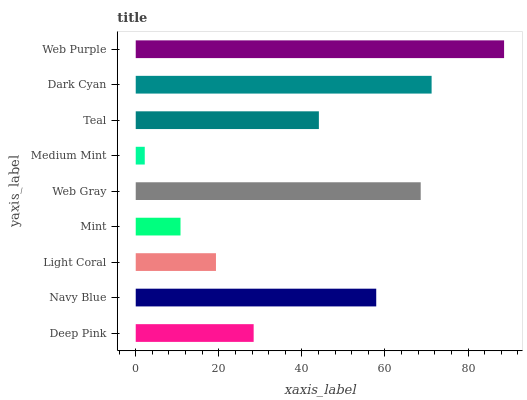Is Medium Mint the minimum?
Answer yes or no. Yes. Is Web Purple the maximum?
Answer yes or no. Yes. Is Navy Blue the minimum?
Answer yes or no. No. Is Navy Blue the maximum?
Answer yes or no. No. Is Navy Blue greater than Deep Pink?
Answer yes or no. Yes. Is Deep Pink less than Navy Blue?
Answer yes or no. Yes. Is Deep Pink greater than Navy Blue?
Answer yes or no. No. Is Navy Blue less than Deep Pink?
Answer yes or no. No. Is Teal the high median?
Answer yes or no. Yes. Is Teal the low median?
Answer yes or no. Yes. Is Medium Mint the high median?
Answer yes or no. No. Is Medium Mint the low median?
Answer yes or no. No. 